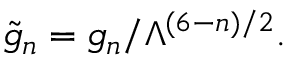<formula> <loc_0><loc_0><loc_500><loc_500>\tilde { g } _ { n } = g _ { n } / \Lambda ^ { ( 6 - n ) / 2 } .</formula> 